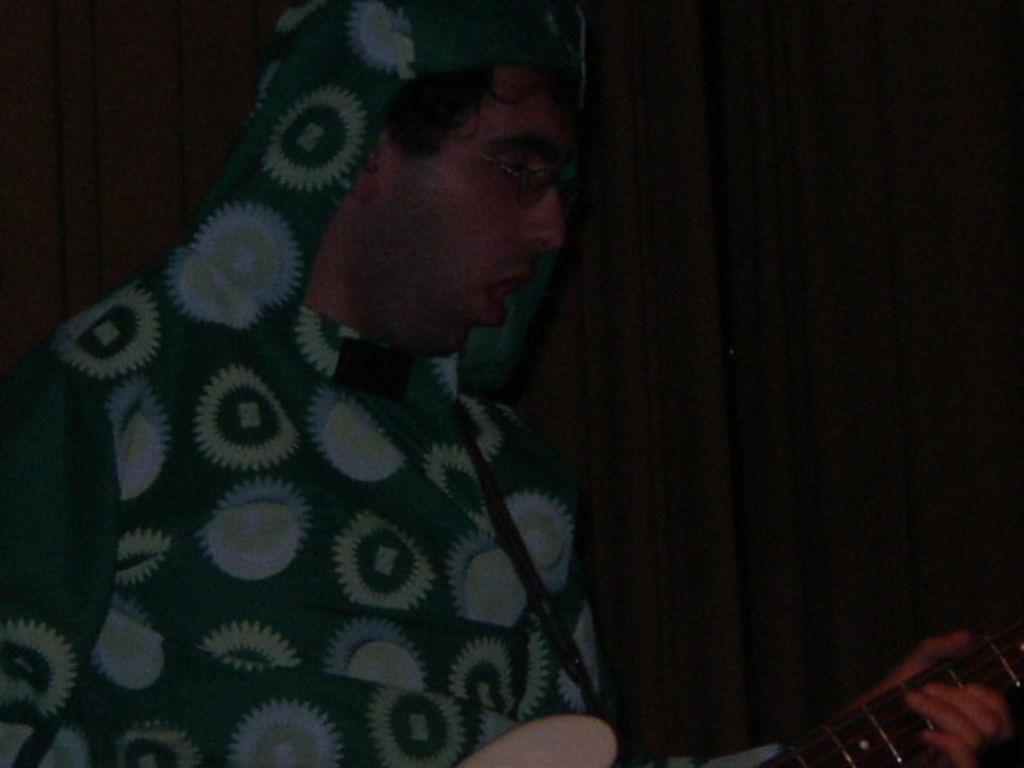Who is the main subject in the image? There is a man in the image. What is the man holding in the image? The man is holding a guitar. How is the man holding the guitar? The man is using his hands to hold the guitar. What accessory is the man wearing in the image? The man is wearing spectacles. How many babies are present in the image? There are no babies present in the image. What is the level of pollution in the image? There is no information about pollution in the image, as it features a man holding a guitar. 